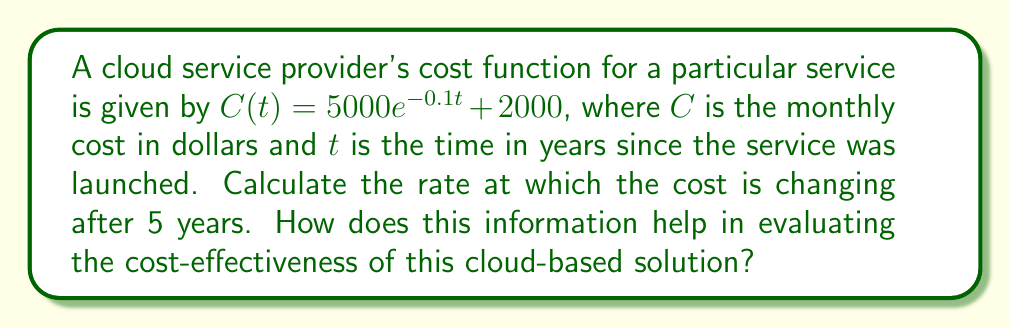Help me with this question. To find the rate of change in the cost after 5 years, we need to calculate the derivative of the cost function $C(t)$ and evaluate it at $t=5$. 

Step 1: Calculate the derivative of $C(t)$
$$\frac{d}{dt}C(t) = \frac{d}{dt}(5000e^{-0.1t} + 2000)$$
$$C'(t) = 5000 \cdot (-0.1) \cdot e^{-0.1t} + 0$$
$$C'(t) = -500e^{-0.1t}$$

Step 2: Evaluate $C'(t)$ at $t=5$
$$C'(5) = -500e^{-0.1(5)}$$
$$C'(5) = -500e^{-0.5}$$
$$C'(5) = -500 \cdot 0.6065 \approx -303.25$$

The negative value indicates that the cost is decreasing at a rate of approximately $303.25 per year after 5 years.

This information helps in evaluating the cost-effectiveness of the cloud-based solution by showing that the costs are decreasing over time, which is beneficial for long-term budget planning. The exponential decay in costs suggests that the service provider is likely achieving economies of scale or improving efficiency over time, making the solution more cost-effective as it matures.
Answer: $-303.25 per year 